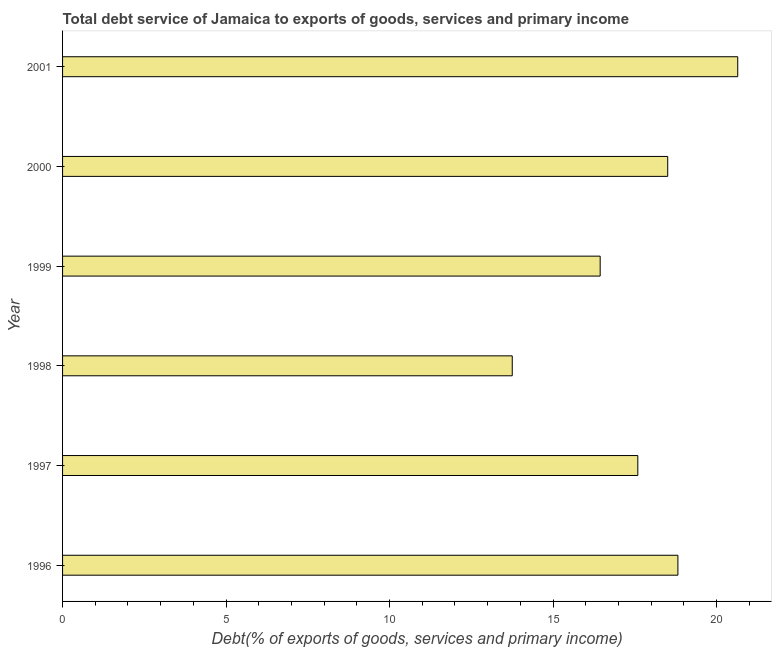Does the graph contain any zero values?
Offer a terse response. No. Does the graph contain grids?
Make the answer very short. No. What is the title of the graph?
Your answer should be very brief. Total debt service of Jamaica to exports of goods, services and primary income. What is the label or title of the X-axis?
Provide a short and direct response. Debt(% of exports of goods, services and primary income). What is the label or title of the Y-axis?
Make the answer very short. Year. What is the total debt service in 1999?
Provide a succinct answer. 16.44. Across all years, what is the maximum total debt service?
Give a very brief answer. 20.65. Across all years, what is the minimum total debt service?
Your response must be concise. 13.75. In which year was the total debt service maximum?
Your answer should be compact. 2001. What is the sum of the total debt service?
Give a very brief answer. 105.76. What is the difference between the total debt service in 1997 and 2001?
Ensure brevity in your answer.  -3.06. What is the average total debt service per year?
Keep it short and to the point. 17.63. What is the median total debt service?
Give a very brief answer. 18.05. Do a majority of the years between 1999 and 2000 (inclusive) have total debt service greater than 13 %?
Provide a succinct answer. Yes. What is the ratio of the total debt service in 1999 to that in 2000?
Ensure brevity in your answer.  0.89. Is the difference between the total debt service in 1999 and 2000 greater than the difference between any two years?
Provide a succinct answer. No. What is the difference between the highest and the second highest total debt service?
Your answer should be very brief. 1.83. What is the difference between the highest and the lowest total debt service?
Your response must be concise. 6.9. How many bars are there?
Make the answer very short. 6. How many years are there in the graph?
Offer a terse response. 6. Are the values on the major ticks of X-axis written in scientific E-notation?
Ensure brevity in your answer.  No. What is the Debt(% of exports of goods, services and primary income) of 1996?
Offer a very short reply. 18.82. What is the Debt(% of exports of goods, services and primary income) of 1997?
Give a very brief answer. 17.59. What is the Debt(% of exports of goods, services and primary income) in 1998?
Make the answer very short. 13.75. What is the Debt(% of exports of goods, services and primary income) of 1999?
Offer a terse response. 16.44. What is the Debt(% of exports of goods, services and primary income) of 2000?
Ensure brevity in your answer.  18.51. What is the Debt(% of exports of goods, services and primary income) of 2001?
Offer a very short reply. 20.65. What is the difference between the Debt(% of exports of goods, services and primary income) in 1996 and 1997?
Ensure brevity in your answer.  1.23. What is the difference between the Debt(% of exports of goods, services and primary income) in 1996 and 1998?
Provide a succinct answer. 5.07. What is the difference between the Debt(% of exports of goods, services and primary income) in 1996 and 1999?
Make the answer very short. 2.38. What is the difference between the Debt(% of exports of goods, services and primary income) in 1996 and 2000?
Your answer should be very brief. 0.31. What is the difference between the Debt(% of exports of goods, services and primary income) in 1996 and 2001?
Make the answer very short. -1.83. What is the difference between the Debt(% of exports of goods, services and primary income) in 1997 and 1998?
Make the answer very short. 3.84. What is the difference between the Debt(% of exports of goods, services and primary income) in 1997 and 1999?
Provide a short and direct response. 1.15. What is the difference between the Debt(% of exports of goods, services and primary income) in 1997 and 2000?
Your answer should be very brief. -0.91. What is the difference between the Debt(% of exports of goods, services and primary income) in 1997 and 2001?
Make the answer very short. -3.06. What is the difference between the Debt(% of exports of goods, services and primary income) in 1998 and 1999?
Give a very brief answer. -2.69. What is the difference between the Debt(% of exports of goods, services and primary income) in 1998 and 2000?
Ensure brevity in your answer.  -4.75. What is the difference between the Debt(% of exports of goods, services and primary income) in 1998 and 2001?
Give a very brief answer. -6.9. What is the difference between the Debt(% of exports of goods, services and primary income) in 1999 and 2000?
Your response must be concise. -2.07. What is the difference between the Debt(% of exports of goods, services and primary income) in 1999 and 2001?
Ensure brevity in your answer.  -4.21. What is the difference between the Debt(% of exports of goods, services and primary income) in 2000 and 2001?
Make the answer very short. -2.14. What is the ratio of the Debt(% of exports of goods, services and primary income) in 1996 to that in 1997?
Ensure brevity in your answer.  1.07. What is the ratio of the Debt(% of exports of goods, services and primary income) in 1996 to that in 1998?
Keep it short and to the point. 1.37. What is the ratio of the Debt(% of exports of goods, services and primary income) in 1996 to that in 1999?
Offer a terse response. 1.15. What is the ratio of the Debt(% of exports of goods, services and primary income) in 1996 to that in 2001?
Provide a short and direct response. 0.91. What is the ratio of the Debt(% of exports of goods, services and primary income) in 1997 to that in 1998?
Keep it short and to the point. 1.28. What is the ratio of the Debt(% of exports of goods, services and primary income) in 1997 to that in 1999?
Provide a succinct answer. 1.07. What is the ratio of the Debt(% of exports of goods, services and primary income) in 1997 to that in 2000?
Keep it short and to the point. 0.95. What is the ratio of the Debt(% of exports of goods, services and primary income) in 1997 to that in 2001?
Ensure brevity in your answer.  0.85. What is the ratio of the Debt(% of exports of goods, services and primary income) in 1998 to that in 1999?
Provide a succinct answer. 0.84. What is the ratio of the Debt(% of exports of goods, services and primary income) in 1998 to that in 2000?
Offer a very short reply. 0.74. What is the ratio of the Debt(% of exports of goods, services and primary income) in 1998 to that in 2001?
Give a very brief answer. 0.67. What is the ratio of the Debt(% of exports of goods, services and primary income) in 1999 to that in 2000?
Ensure brevity in your answer.  0.89. What is the ratio of the Debt(% of exports of goods, services and primary income) in 1999 to that in 2001?
Give a very brief answer. 0.8. What is the ratio of the Debt(% of exports of goods, services and primary income) in 2000 to that in 2001?
Offer a terse response. 0.9. 